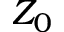Convert formula to latex. <formula><loc_0><loc_0><loc_500><loc_500>Z _ { 0 }</formula> 